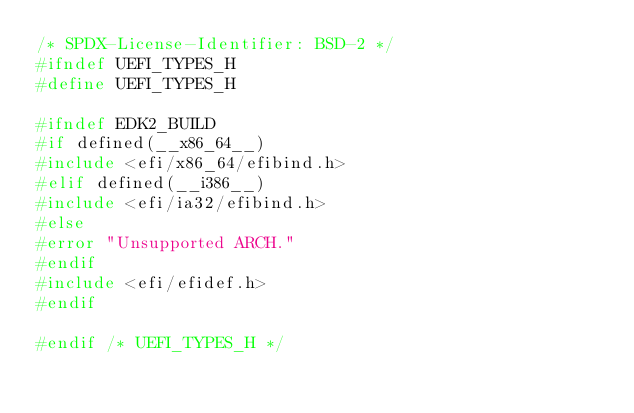Convert code to text. <code><loc_0><loc_0><loc_500><loc_500><_C_>/* SPDX-License-Identifier: BSD-2 */
#ifndef UEFI_TYPES_H
#define UEFI_TYPES_H

#ifndef EDK2_BUILD
#if defined(__x86_64__)
#include <efi/x86_64/efibind.h>
#elif defined(__i386__)
#include <efi/ia32/efibind.h>
#else
#error "Unsupported ARCH."
#endif
#include <efi/efidef.h>
#endif

#endif /* UEFI_TYPES_H */
</code> 